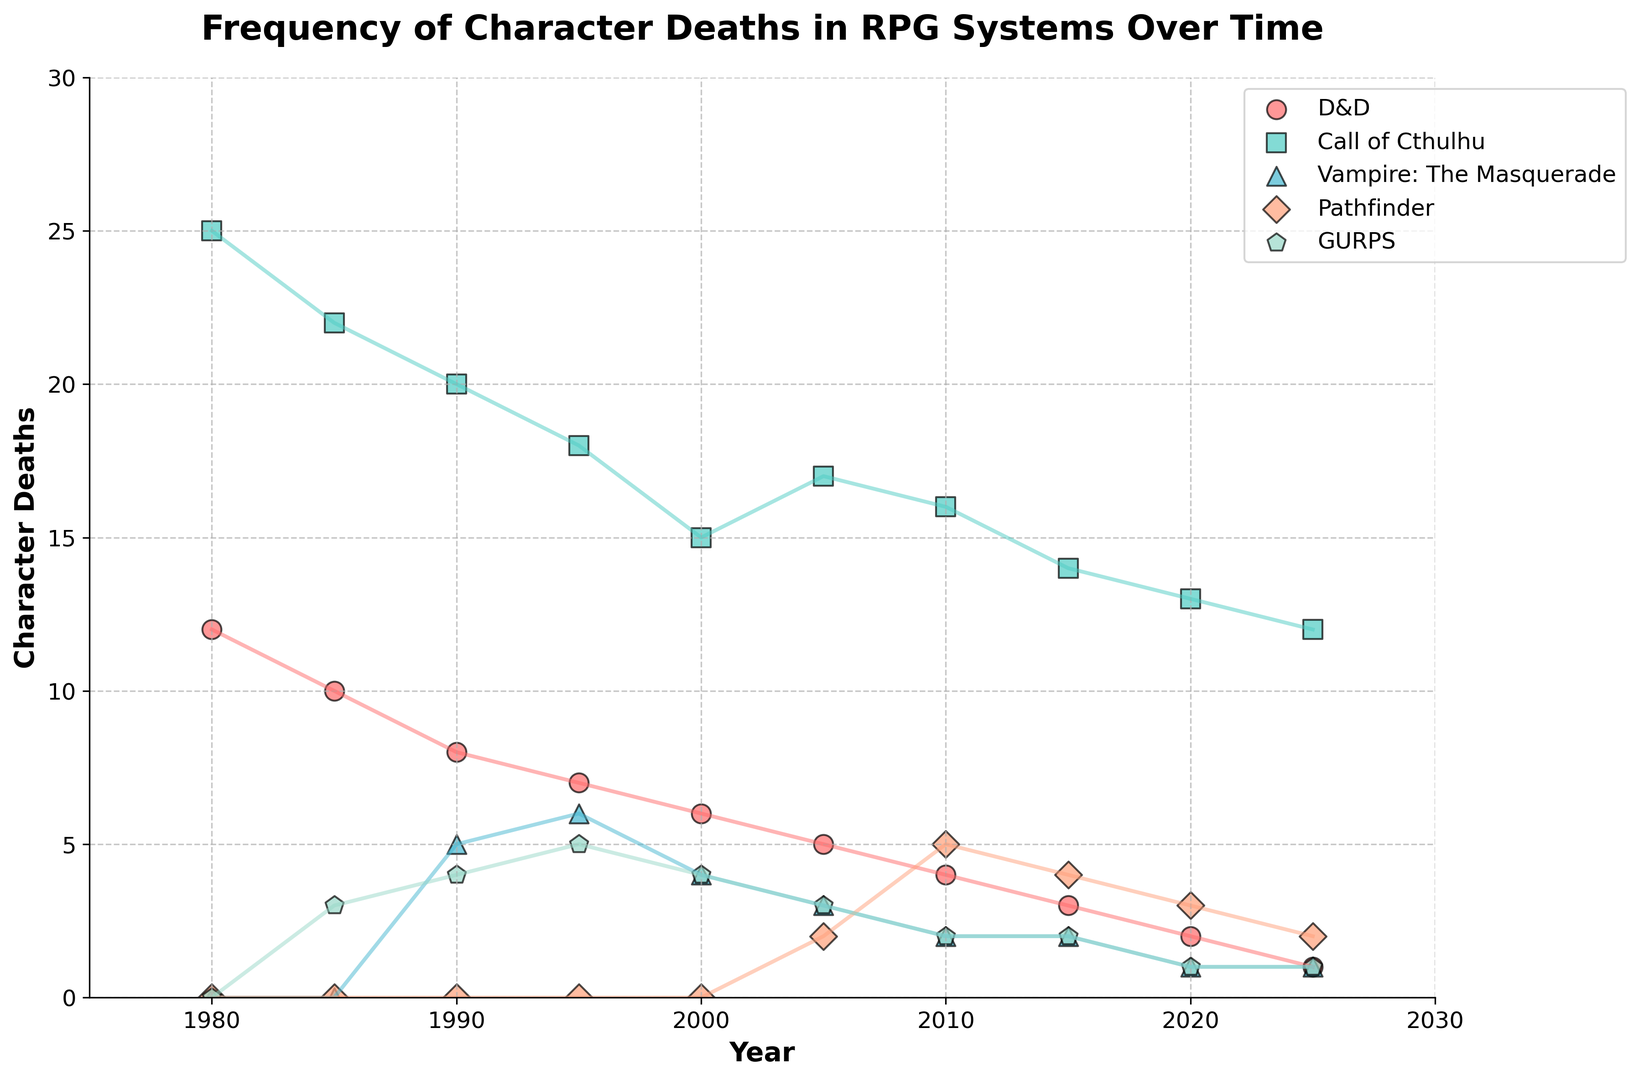What RPG system had the highest frequency of character deaths in 1980? In 1980, the plot shows three RPG systems with data points: D&D with 12, Call of Cthulhu with 25, and Vampire: The Masquerade with 0. Call of Cthulhu has the highest value.
Answer: Call of Cthulhu How did the frequency of character deaths in Vampire: The Masquerade change between 1990 and 2020? The frequency in Vampire: The Masquerade started at 5 in 1990 and decreased to 1 in 2020.
Answer: Decreased Which RPG system had the most significant decrease in character deaths from 1980 to 2025? Analyzing the change from 1980 to 2025, D&D decreased by (12 - 1 = 11), Call of Cthulhu by (25 - 12 = 13), and GURPS by (0 - 1 = -1 since GURPS started later). Call of Cthulhu had the largest decrease.
Answer: Call of Cthulhu By how much did the character deaths in Pathfinder increase from 2005 to 2010? For Pathfinder, it increased from 2 in 2005 to 5 in 2010, making the increase (5 - 2).
Answer: 3 In which year did D&D and Pathfinder have the same frequency of character deaths? By examining the trend lines, we see that in 2025, both D&D and Pathfinder hit the same frequency of character deaths, which is 1.
Answer: 2025 Which RPG system had the lowest frequency of character deaths in 2020? In 2020, GURPS had the lowest with 1, while D&D had 2, Call of Cthulhu had 13, Vampire: The Masquerade had 1, and Pathfinder had 3.
Answer: GURPS How many character deaths were recorded for Call of Cthulhu over all years? Summing each value for Call of Cthulhu from 1980 to 2025: 25 + 22 + 20 + 18 + 15 + 17 + 16 + 14 + 13 + 12, the total is 172.
Answer: 172 Which system shows a consistent decline in character deaths over time? Observing each system's trend from 1980 to 2025, D&D has a consistent decline without any increases.
Answer: D&D 